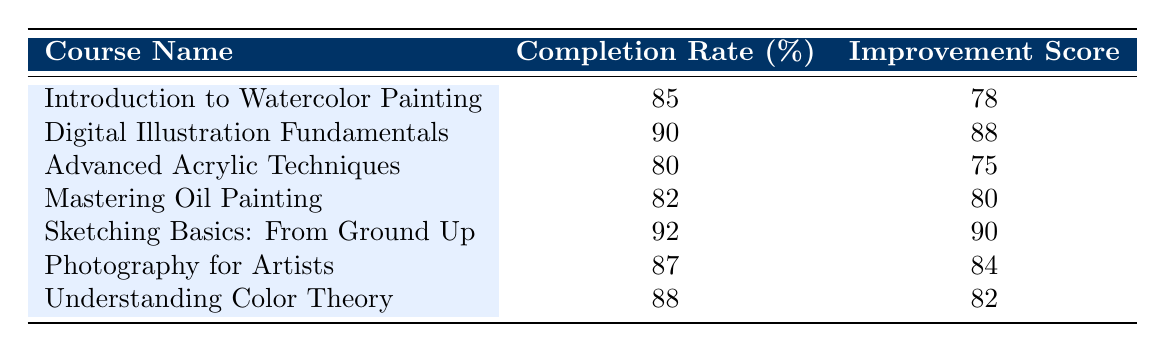What is the completion rate for the course "Sketching Basics: From Ground Up"? The table shows the completion rate for "Sketching Basics: From Ground Up" listed as 92%.
Answer: 92 Which course has the highest student improvement score? By comparing the improvement scores listed, "Sketching Basics: From Ground Up" has the highest score of 90.
Answer: Sketching Basics: From Ground Up What is the average completion rate of all courses listed? To find the average, we sum the completion rates: (85 + 90 + 80 + 82 + 92 + 87 + 88) = 514, and divide by 7 (the number of courses): 514 / 7 = 73.43 (rounded to 73.43).
Answer: 73.43 Is the completion rate of "Digital Illustration Fundamentals" higher than the completion rate of "Mastering Oil Painting"? "Digital Illustration Fundamentals" has a completion rate of 90%, while "Mastering Oil Painting" has a rate of 82%. Since 90 is greater than 82, the answer is yes.
Answer: Yes What is the difference in student improvement scores between the best and worst performing courses? The highest improvement score is 90 (from "Sketching Basics: From Ground Up") and the lowest is 75 (from "Advanced Acrylic Techniques"). The difference is 90 - 75 = 15.
Answer: 15 